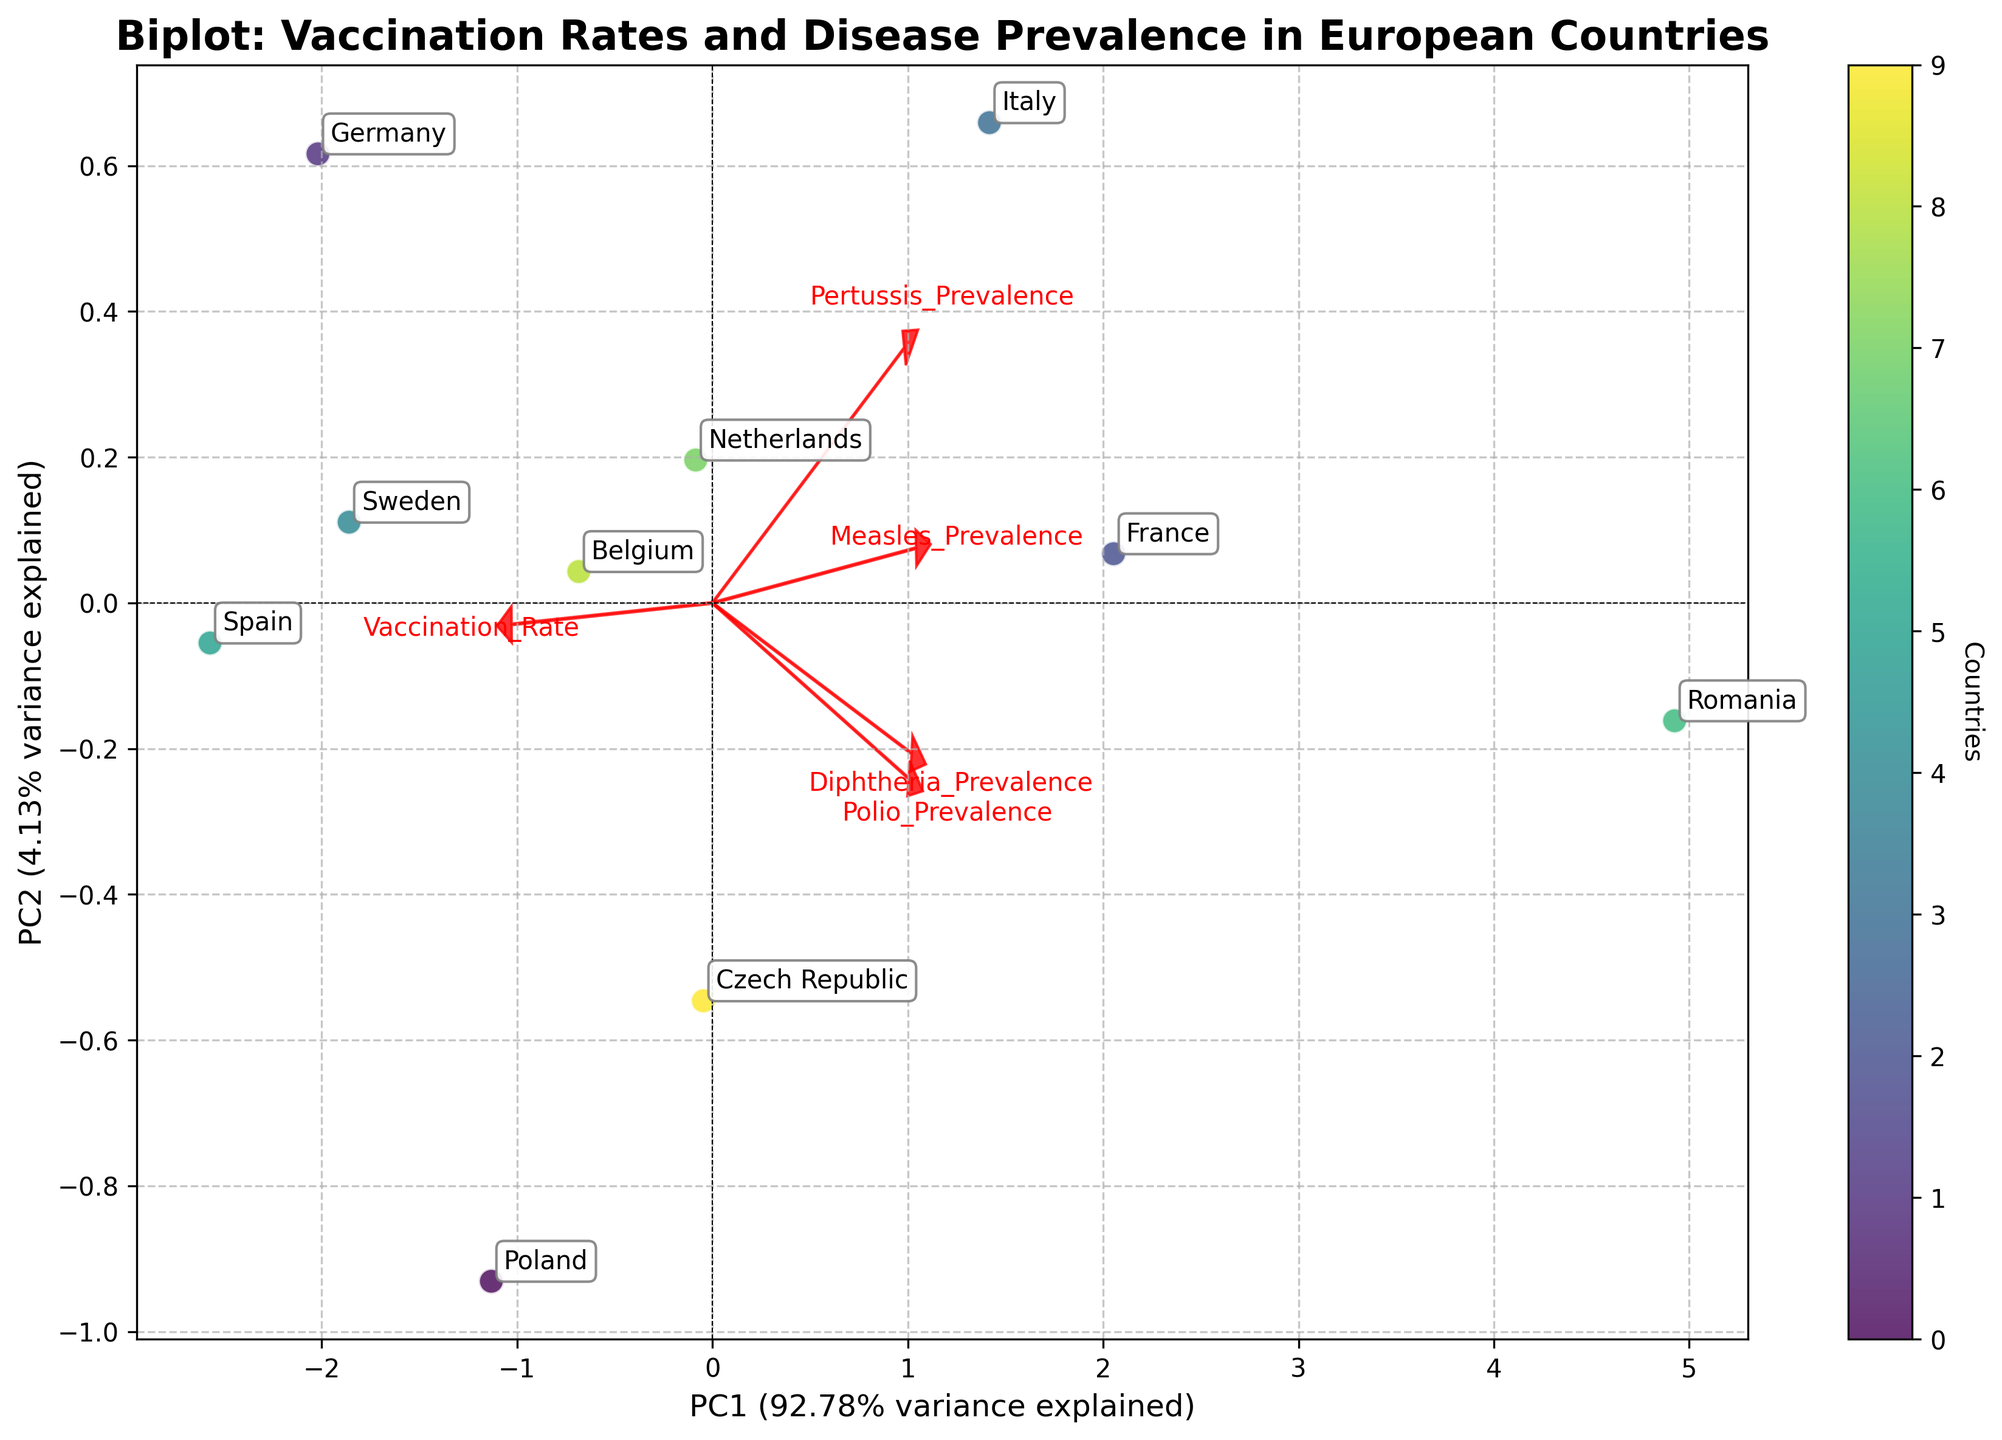What is the title of the plot? The title of the plot is directly shown at the top of the figure.
Answer: Biplot: Vaccination Rates and Disease Prevalence in European Countries Which country has the highest vaccination rate? The point representing the country with the highest vaccination rate can be identified by looking at the labels on the plot and their relative positions.
Answer: Spain Which axis explains more variance? The variance explained by each axis is shown in the parentheses next to the axis labels. The x-axis (PC1) shows a larger percentage.
Answer: PC1 Which disease has the largest arrow in the eigenvectors? The length of the arrows representing eigenvectors indicates the magnitude of each feature. By comparing the length of the arrows, measles shows the largest arrow.
Answer: Measles How do Poland's measles prevalence and vaccination rate compare to Romania's? Poland and Romania can be located on the plot using their labels. By comparing their locations relative to the measles and vaccination rate eigenvectors, one can see the direction and proximity to the vectors.
Answer: Poland has a higher vaccination rate but lower measles prevalence than Romania Which diseases are more closely associated with PC1? By looking at the direction and proximity of the arrows to the PC1 axis, measles and pertussis appear more aligned with PC1.
Answer: Measles and Pertussis What does a closer proximity to the origin point indicate about a country's data? The origin point (0, 0) typically represents the mean value of the dataset. A country closer to the origin indicates it has values close to the average rates of the features.
Answer: Near average vaccination rates and disease prevalence Which countries have a vaccination rate higher than 95%? By referring to the vicinity of countries' points on the plot to the vaccination rate eigenvector and noting the labels, we identify the relevant countries.
Answer: Poland, Germany, Sweden, and Spain What relationship can be inferred between vaccination rate and disease prevalence from the arrow directions? If the vaccination rate arrow points in a direction generally opposite to disease prevalence arrows, it indicates a negative correlation between high vaccination rates and disease prevalence.
Answer: Negative correlation 